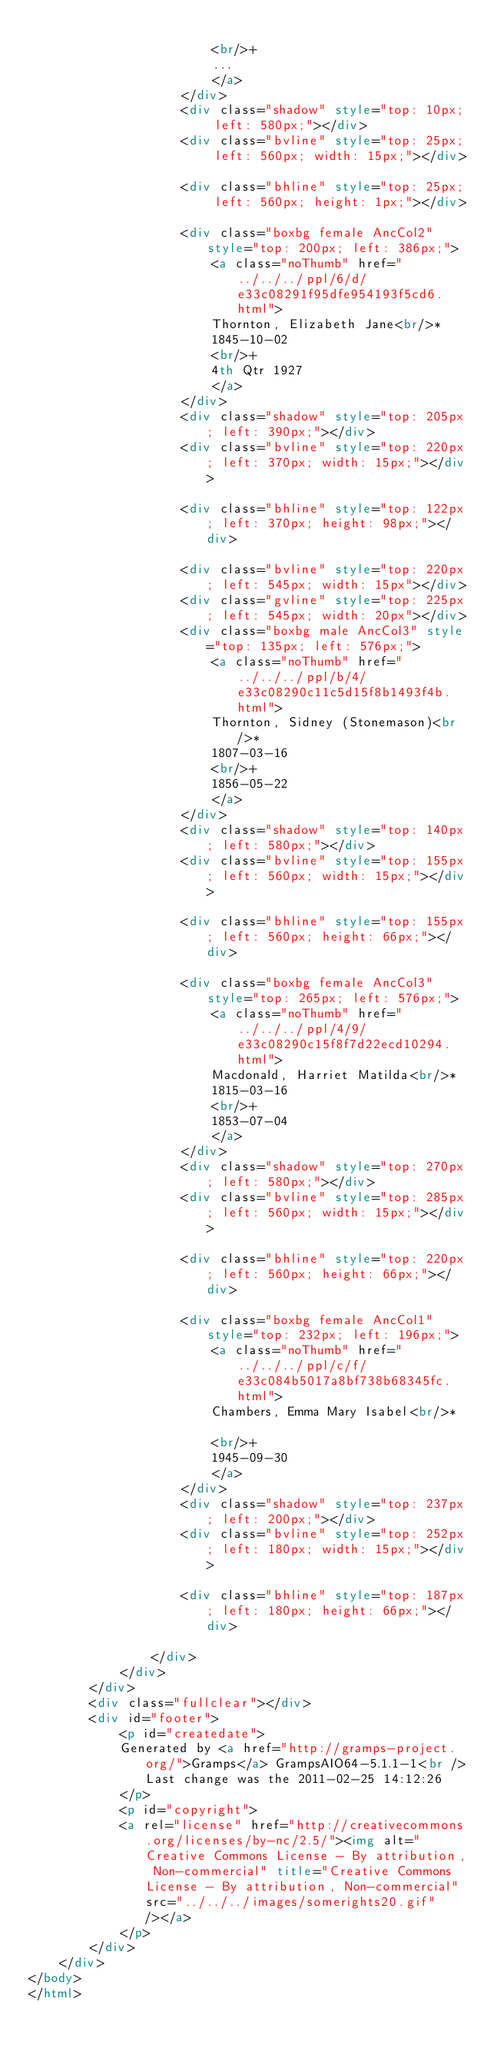<code> <loc_0><loc_0><loc_500><loc_500><_HTML_>						
						<br/>+
						...
						</a>
					</div>
					<div class="shadow" style="top: 10px; left: 580px;"></div>
					<div class="bvline" style="top: 25px; left: 560px; width: 15px;"></div>
				
					<div class="bhline" style="top: 25px; left: 560px; height: 1px;"></div>
				
					<div class="boxbg female AncCol2" style="top: 200px; left: 386px;">
						<a class="noThumb" href="../../../ppl/6/d/e33c08291f95dfe954193f5cd6.html">
						Thornton, Elizabeth Jane<br/>*
						1845-10-02
						<br/>+
						4th Qtr 1927
						</a>
					</div>
					<div class="shadow" style="top: 205px; left: 390px;"></div>
					<div class="bvline" style="top: 220px; left: 370px; width: 15px;"></div>
				
					<div class="bhline" style="top: 122px; left: 370px; height: 98px;"></div>
				
					<div class="bvline" style="top: 220px; left: 545px; width: 15px"></div>
					<div class="gvline" style="top: 225px; left: 545px; width: 20px"></div>
					<div class="boxbg male AncCol3" style="top: 135px; left: 576px;">
						<a class="noThumb" href="../../../ppl/b/4/e33c08290c11c5d15f8b1493f4b.html">
						Thornton, Sidney (Stonemason)<br/>*
						1807-03-16
						<br/>+
						1856-05-22
						</a>
					</div>
					<div class="shadow" style="top: 140px; left: 580px;"></div>
					<div class="bvline" style="top: 155px; left: 560px; width: 15px;"></div>
				
					<div class="bhline" style="top: 155px; left: 560px; height: 66px;"></div>
				
					<div class="boxbg female AncCol3" style="top: 265px; left: 576px;">
						<a class="noThumb" href="../../../ppl/4/9/e33c08290c15f8f7d22ecd10294.html">
						Macdonald, Harriet Matilda<br/>*
						1815-03-16
						<br/>+
						1853-07-04
						</a>
					</div>
					<div class="shadow" style="top: 270px; left: 580px;"></div>
					<div class="bvline" style="top: 285px; left: 560px; width: 15px;"></div>
				
					<div class="bhline" style="top: 220px; left: 560px; height: 66px;"></div>
				
					<div class="boxbg female AncCol1" style="top: 232px; left: 196px;">
						<a class="noThumb" href="../../../ppl/c/f/e33c084b5017a8bf738b68345fc.html">
						Chambers, Emma Mary Isabel<br/>*
						
						<br/>+
						1945-09-30
						</a>
					</div>
					<div class="shadow" style="top: 237px; left: 200px;"></div>
					<div class="bvline" style="top: 252px; left: 180px; width: 15px;"></div>
				
					<div class="bhline" style="top: 187px; left: 180px; height: 66px;"></div>
				
				</div>
			</div>
		</div>
		<div class="fullclear"></div>
		<div id="footer">
			<p id="createdate">
			Generated by <a href="http://gramps-project.org/">Gramps</a> GrampsAIO64-5.1.1-1<br />Last change was the 2011-02-25 14:12:26
			</p>
			<p id="copyright">
			<a rel="license" href="http://creativecommons.org/licenses/by-nc/2.5/"><img alt="Creative Commons License - By attribution, Non-commercial" title="Creative Commons License - By attribution, Non-commercial" src="../../../images/somerights20.gif" /></a>
			</p>
		</div>
	</div>
</body>
</html>
</code> 